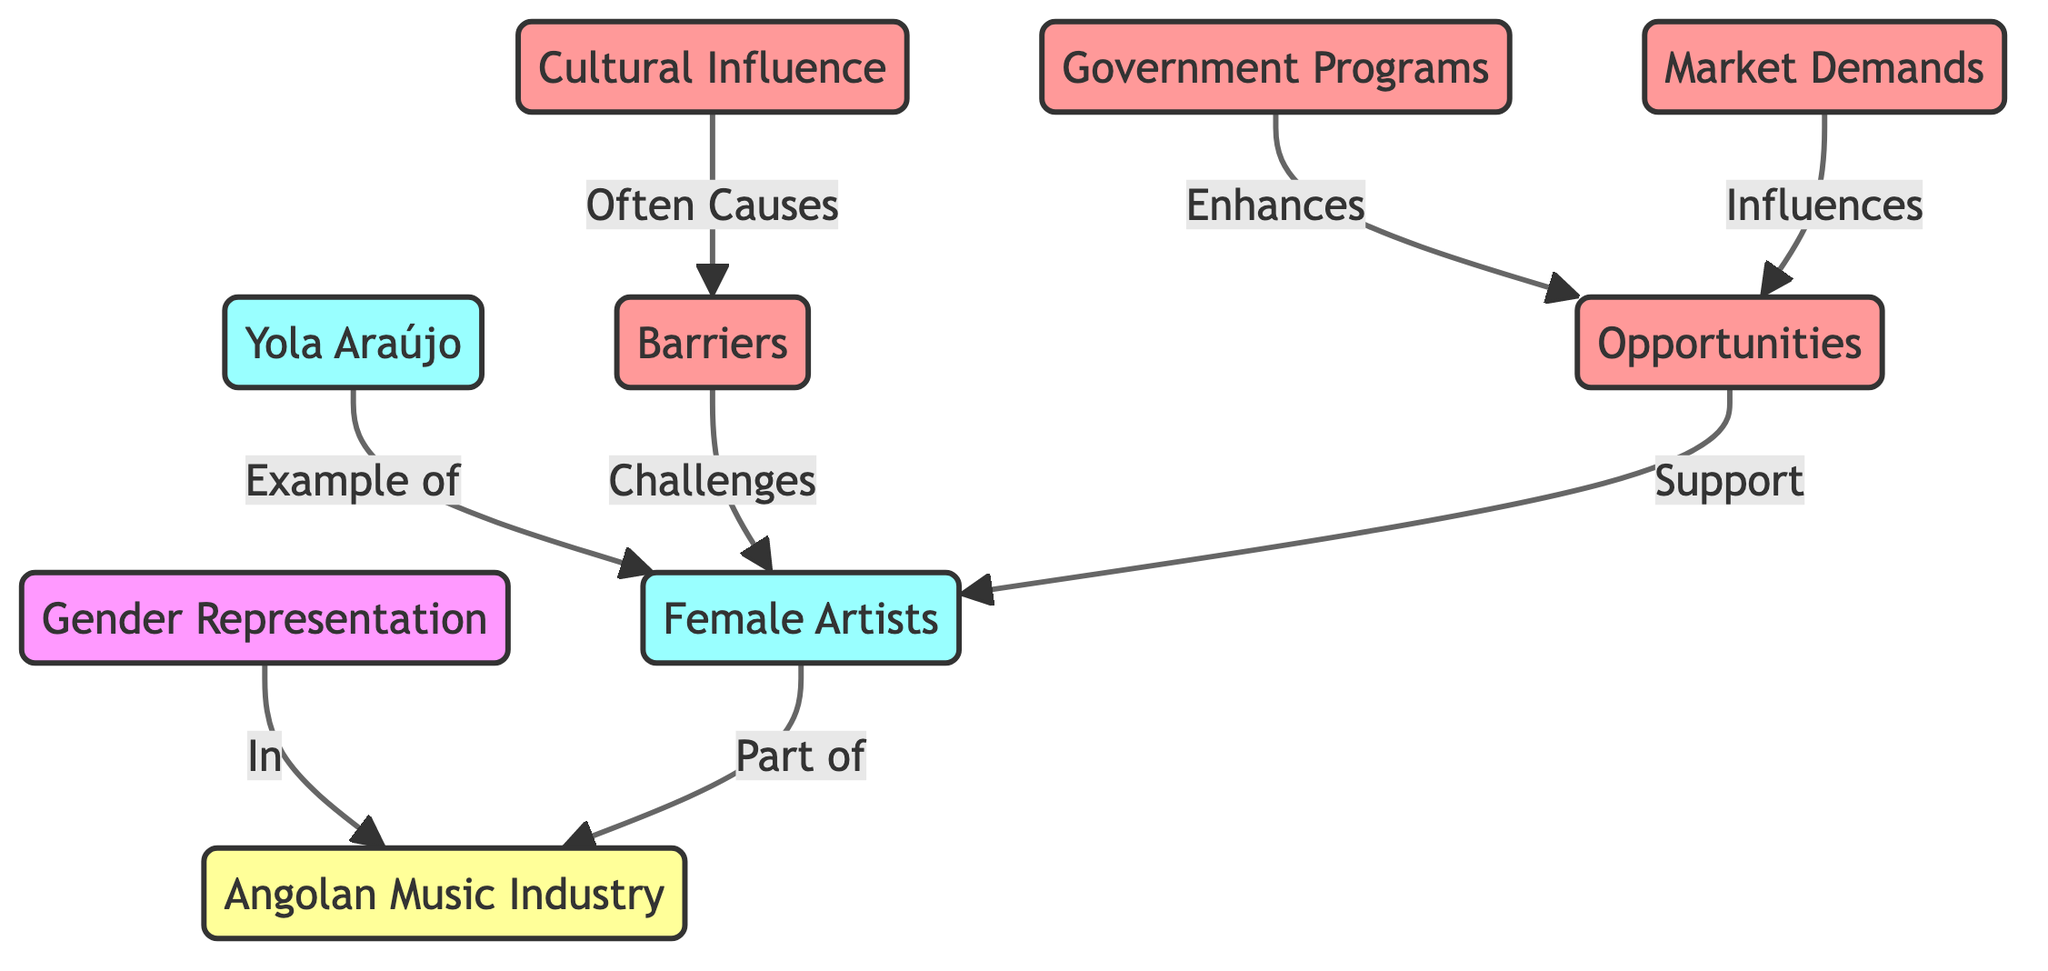What is the main focus of the diagram? The main focus of the diagram is on "Gender Representation" in the context of the Angolan music industry. This is identified as the central node from which all other related elements branch out.
Answer: Gender Representation How many artist nodes are there in the diagram? The diagram has three artist nodes: "Female Artists", "Yola Araújo", and "female artists" references. Since "Yola Araújo" is a specific instance of "Female Artists", there is one unique artist node.
Answer: 2 What factor is shown to enhance opportunities for female artists? "Government Programs" is depicted as a factor that enhances opportunities for female artists, as it is linked directly to "Opportunities" with a supporting relationship.
Answer: Government Programs What relationship does "Cultural Influence" have with the barriers? "Cultural Influence" is shown to often cause barriers for female artists, which indicates that societal norms and traditions can negatively impact their representation and opportunities in music.
Answer: Often Causes How does "Market Demands" impact female artists? "Market Demands" influences opportunities for female artists, suggesting that the commercial viability of music genres can create or limit chances for women in the industry depending on public preferences.
Answer: Influences Which female artist is specifically exemplified in the diagram? "Yola Araújo" is specifically exemplified as an important representation of female artists in the Angolan music industry, connected as an example node under "Female Artists."
Answer: Yola Araújo What challenges are identified for female artists? The diagram identifies "Barriers" as challenges faced by female artists, which are linked directly to the node of female artists, indicating various obstacles in their professional environment.
Answer: Barriers What influences opportunities for female artists besides government programs? Besides government programs, "Market Demands" also influences opportunities, showing that both public preferences and institutional support contribute to female artists' success.
Answer: Market Demands What type of diagram is this specifically categorized as? This diagram is categorized as a "Social Science Diagram" as it explores societal dynamics, specifically gender representation within the Angolan music industry.
Answer: Social Science Diagram 